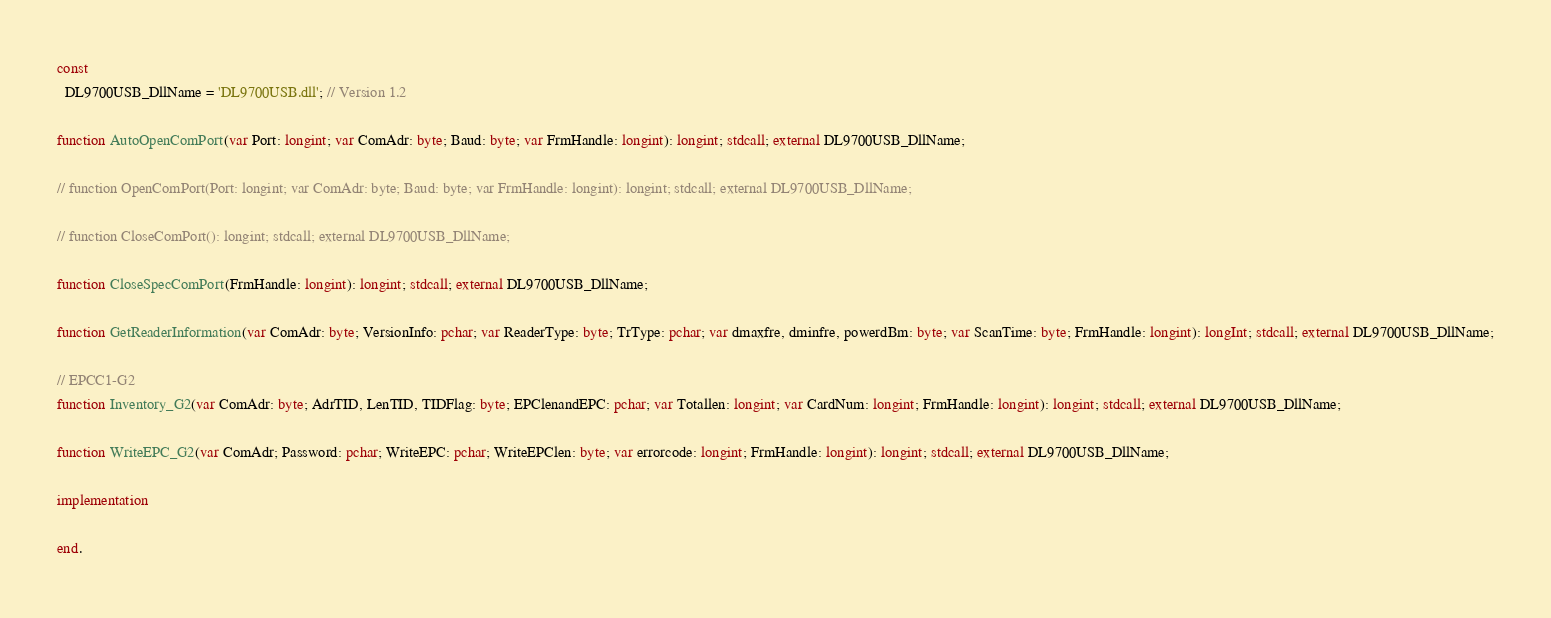<code> <loc_0><loc_0><loc_500><loc_500><_Pascal_>
const
  DL9700USB_DllName = 'DL9700USB.dll'; // Version 1.2

function AutoOpenComPort(var Port: longint; var ComAdr: byte; Baud: byte; var FrmHandle: longint): longint; stdcall; external DL9700USB_DllName;

// function OpenComPort(Port: longint; var ComAdr: byte; Baud: byte; var FrmHandle: longint): longint; stdcall; external DL9700USB_DllName;

// function CloseComPort(): longint; stdcall; external DL9700USB_DllName;

function CloseSpecComPort(FrmHandle: longint): longint; stdcall; external DL9700USB_DllName;

function GetReaderInformation(var ComAdr: byte; VersionInfo: pchar; var ReaderType: byte; TrType: pchar; var dmaxfre, dminfre, powerdBm: byte; var ScanTime: byte; FrmHandle: longint): longInt; stdcall; external DL9700USB_DllName;

// EPCC1-G2
function Inventory_G2(var ComAdr: byte; AdrTID, LenTID, TIDFlag: byte; EPClenandEPC: pchar; var Totallen: longint; var CardNum: longint; FrmHandle: longint): longint; stdcall; external DL9700USB_DllName;

function WriteEPC_G2(var ComAdr; Password: pchar; WriteEPC: pchar; WriteEPClen: byte; var errorcode: longint; FrmHandle: longint): longint; stdcall; external DL9700USB_DllName;

implementation

end.
</code> 